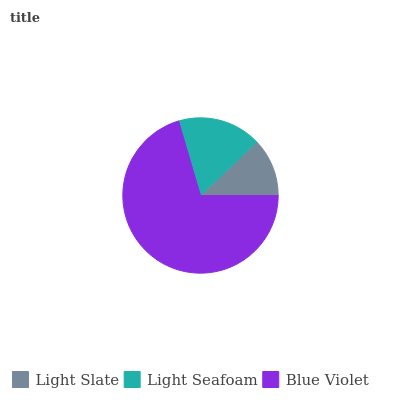Is Light Slate the minimum?
Answer yes or no. Yes. Is Blue Violet the maximum?
Answer yes or no. Yes. Is Light Seafoam the minimum?
Answer yes or no. No. Is Light Seafoam the maximum?
Answer yes or no. No. Is Light Seafoam greater than Light Slate?
Answer yes or no. Yes. Is Light Slate less than Light Seafoam?
Answer yes or no. Yes. Is Light Slate greater than Light Seafoam?
Answer yes or no. No. Is Light Seafoam less than Light Slate?
Answer yes or no. No. Is Light Seafoam the high median?
Answer yes or no. Yes. Is Light Seafoam the low median?
Answer yes or no. Yes. Is Blue Violet the high median?
Answer yes or no. No. Is Light Slate the low median?
Answer yes or no. No. 